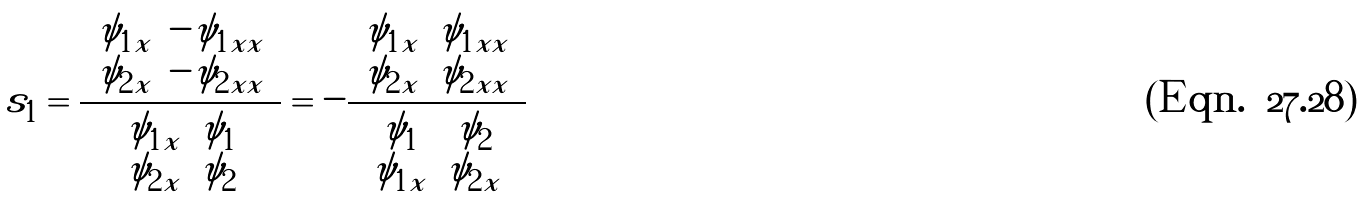Convert formula to latex. <formula><loc_0><loc_0><loc_500><loc_500>s _ { 1 } = \frac { \left | \begin{array} { c c } \psi _ { 1 x } & - \psi _ { 1 x x } \\ \psi _ { 2 x } & - \psi _ { 2 x x } \end{array} \right | } { \left | \begin{array} { c c } \psi _ { 1 x } & \psi _ { 1 } \\ \psi _ { 2 x } & \psi _ { 2 } \end{array} \right | } = - \frac { \left | \begin{array} { c c } \psi _ { 1 x } & \psi _ { 1 x x } \\ \psi _ { 2 x } & \psi _ { 2 x x } \end{array} \right | } { \left | \begin{array} { c c } \psi _ { 1 } & \psi _ { 2 } \\ \psi _ { 1 x } & \psi _ { 2 x } \end{array} \right | }</formula> 